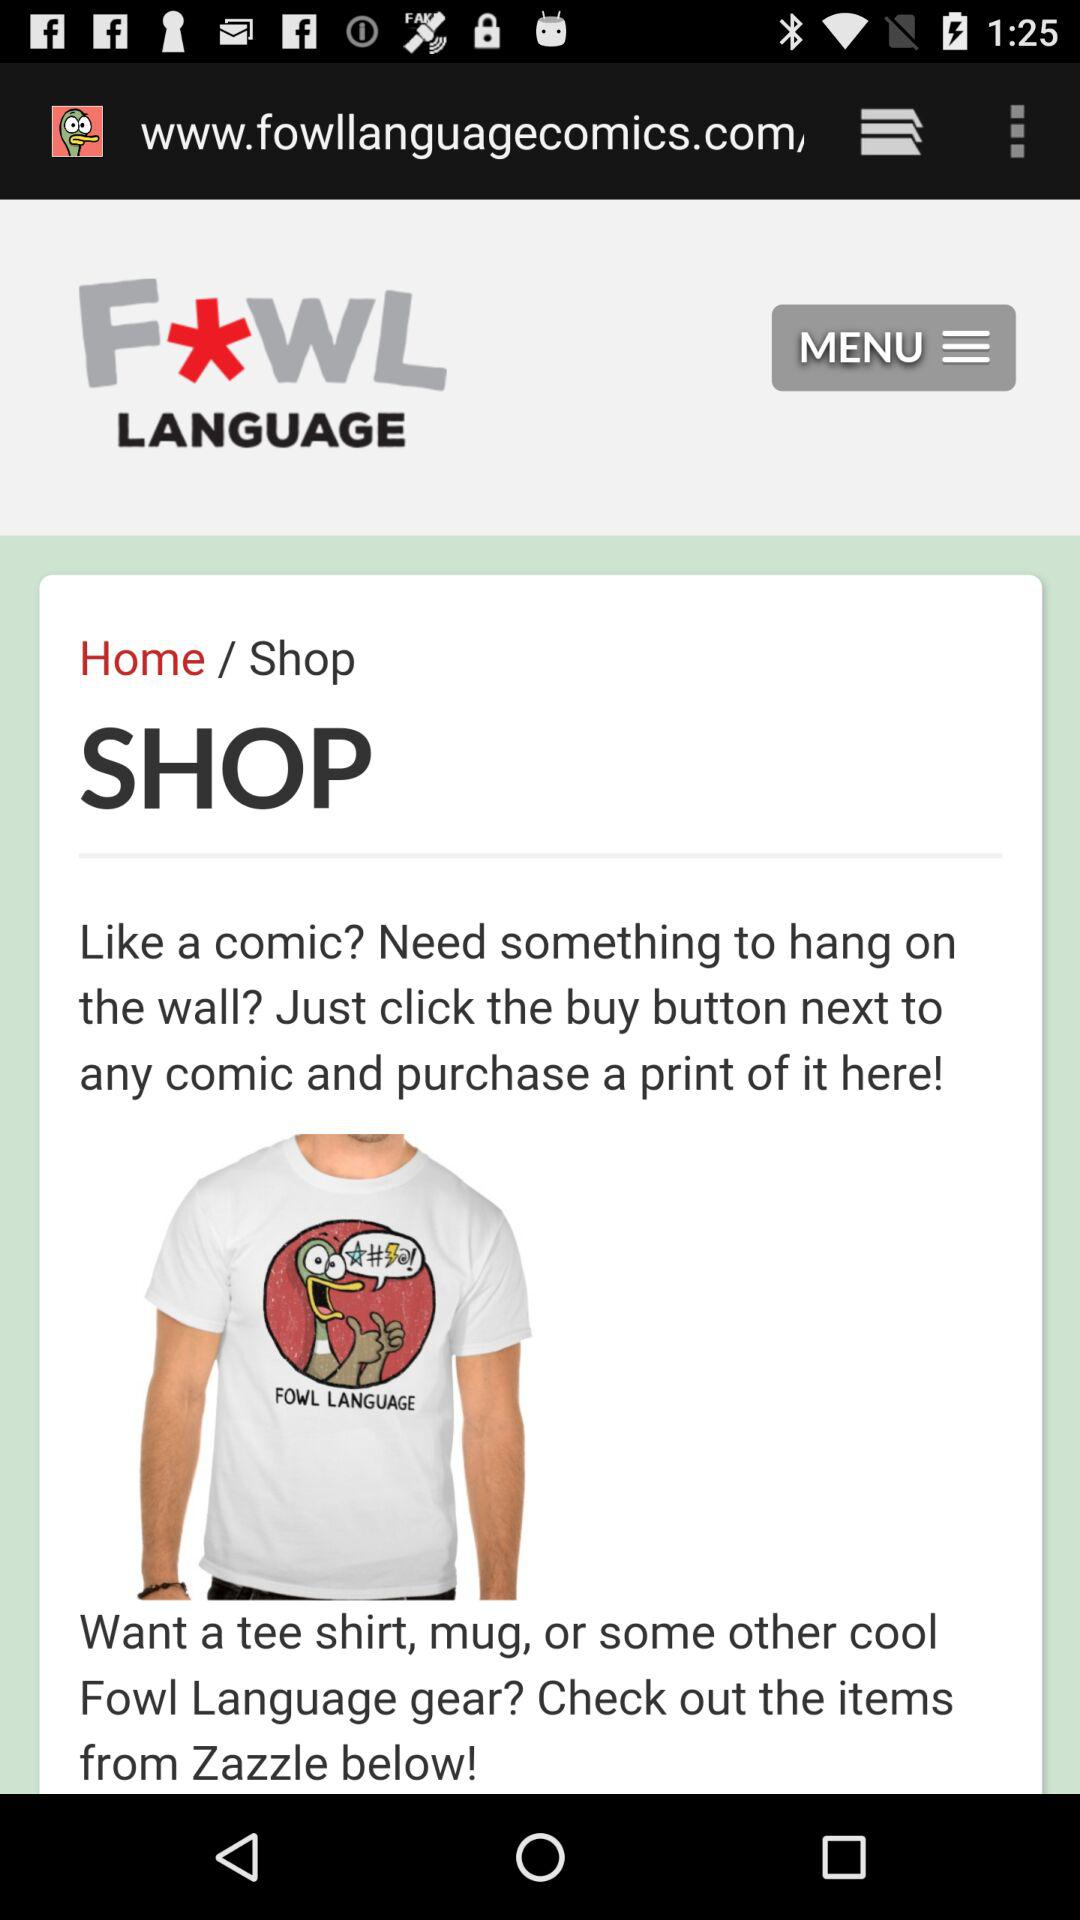What is the application name?
When the provided information is insufficient, respond with <no answer>. <no answer> 